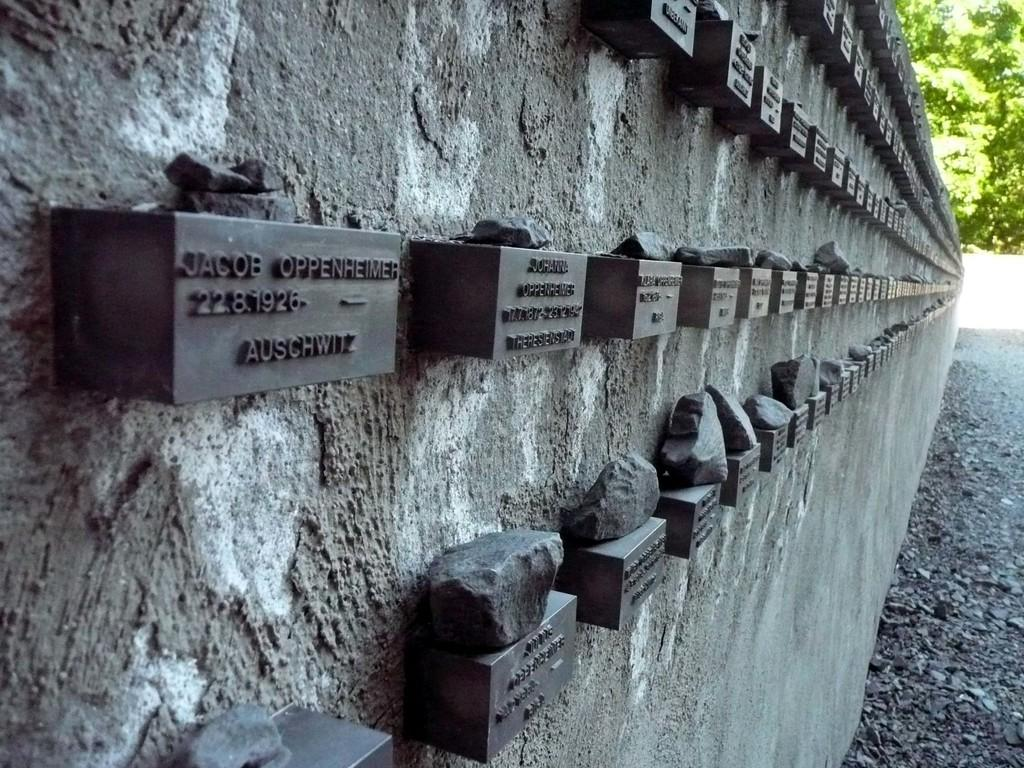Where was the image taken? The image was taken outdoors. What can be seen on the left side of the image? There is a wall with many bricks on the left side of the image. What is written or depicted on the wall? There is text on the wall. What type of vegetation is visible on the right side of the image? There are a few trees on the right side of the image. What type of pen is the cook using to write the lunch menu on the wall? There is no pen, cook, or lunch menu present in the image. 